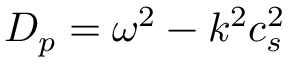<formula> <loc_0><loc_0><loc_500><loc_500>D _ { p } = \omega ^ { 2 } - k ^ { 2 } c _ { s } ^ { 2 }</formula> 